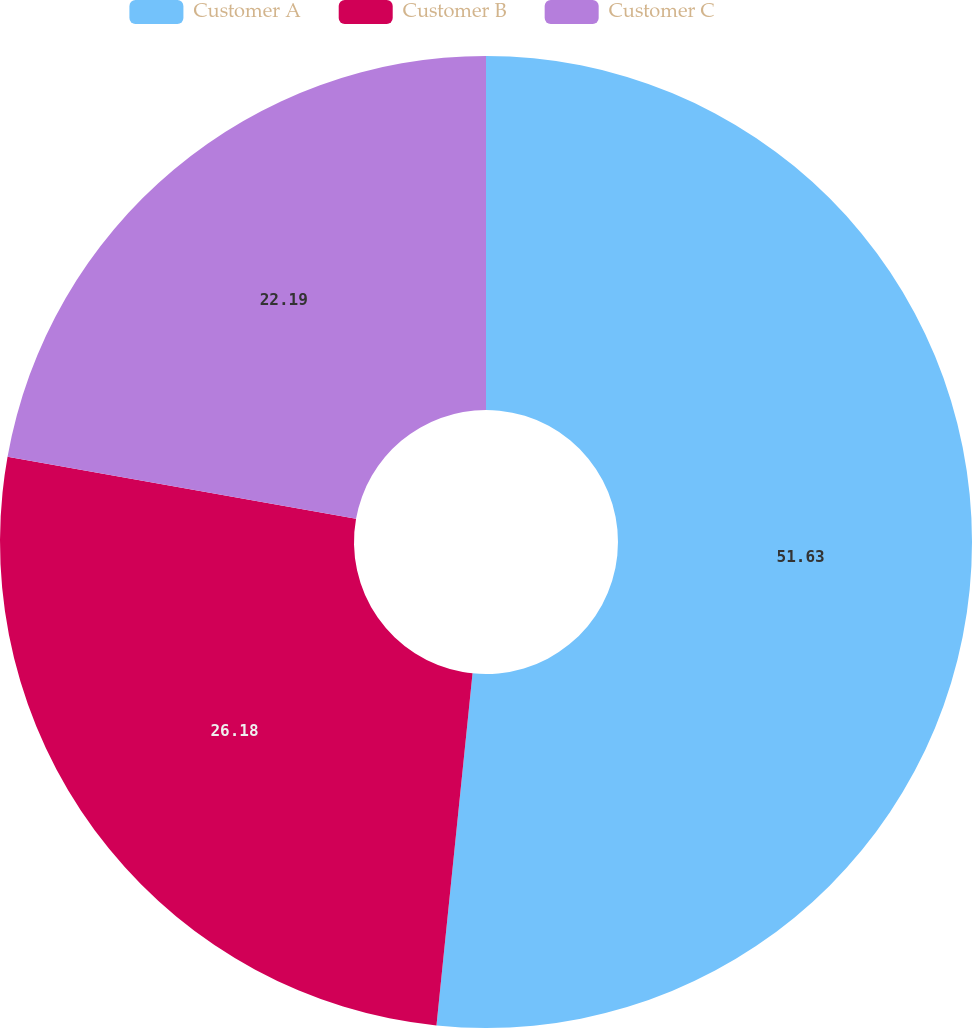Convert chart to OTSL. <chart><loc_0><loc_0><loc_500><loc_500><pie_chart><fcel>Customer A<fcel>Customer B<fcel>Customer C<nl><fcel>51.62%<fcel>26.18%<fcel>22.19%<nl></chart> 